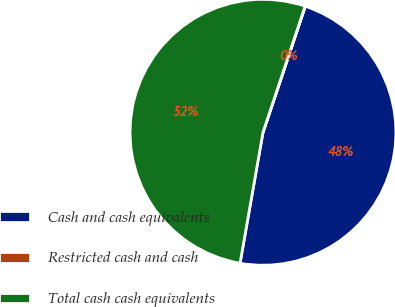<chart> <loc_0><loc_0><loc_500><loc_500><pie_chart><fcel>Cash and cash equivalents<fcel>Restricted cash and cash<fcel>Total cash cash equivalents<nl><fcel>47.61%<fcel>0.03%<fcel>52.37%<nl></chart> 